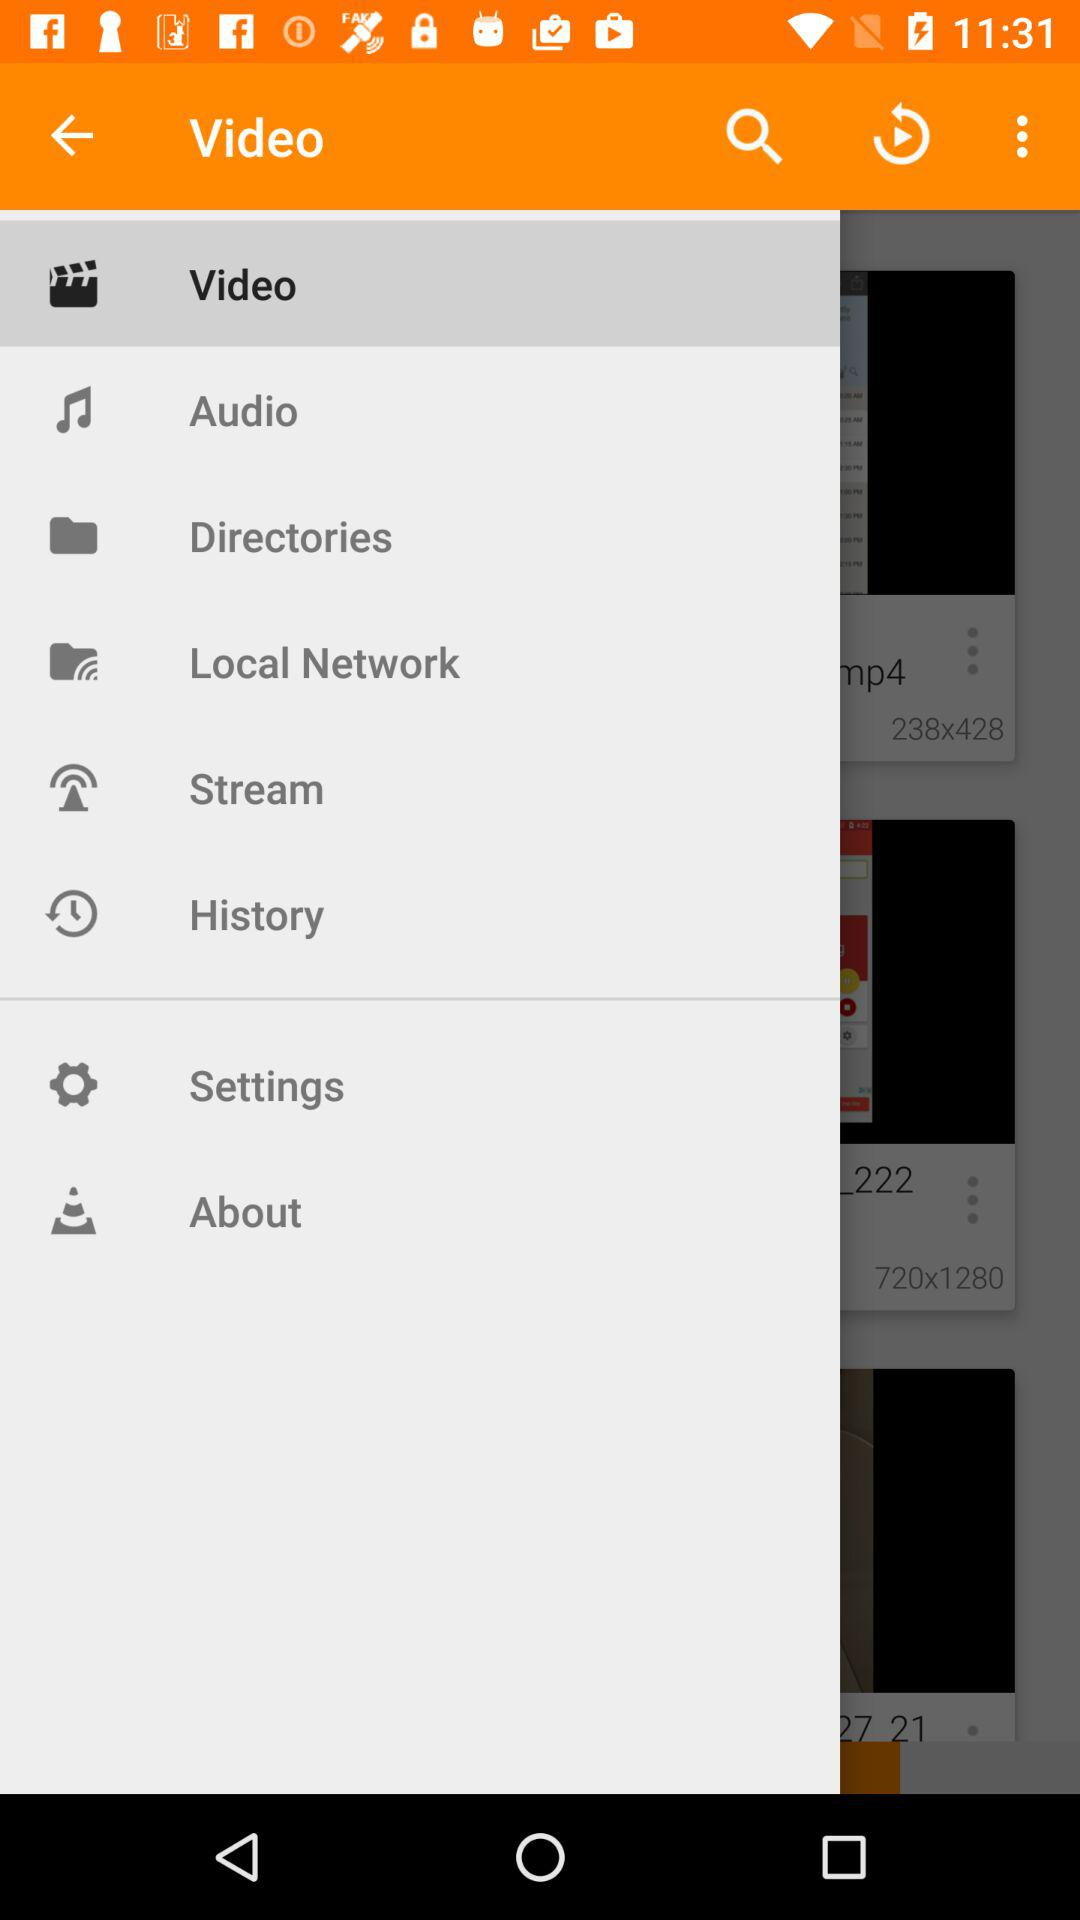Which item is selected in the menu? The selected item is "Video". 